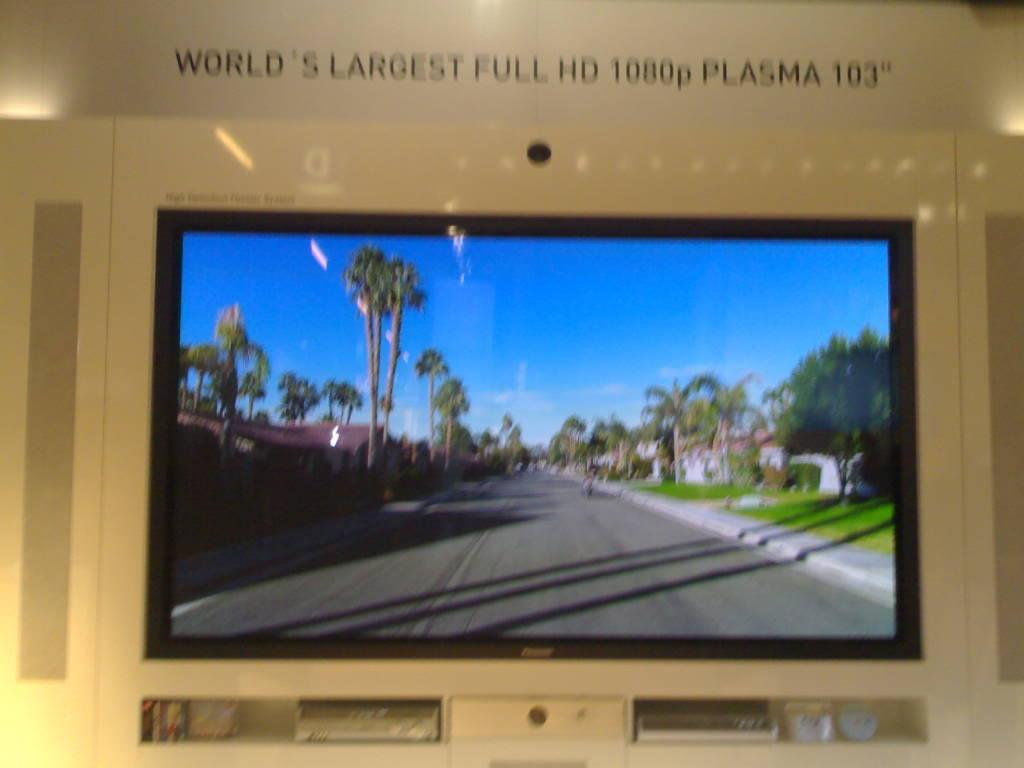<image>
Describe the image concisely. An ad picture with the world's largest plasma tv with 103 inches of screen. 